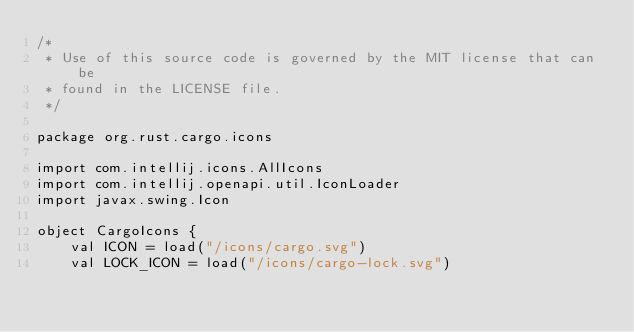<code> <loc_0><loc_0><loc_500><loc_500><_Kotlin_>/*
 * Use of this source code is governed by the MIT license that can be
 * found in the LICENSE file.
 */

package org.rust.cargo.icons

import com.intellij.icons.AllIcons
import com.intellij.openapi.util.IconLoader
import javax.swing.Icon

object CargoIcons {
    val ICON = load("/icons/cargo.svg")
    val LOCK_ICON = load("/icons/cargo-lock.svg")</code> 